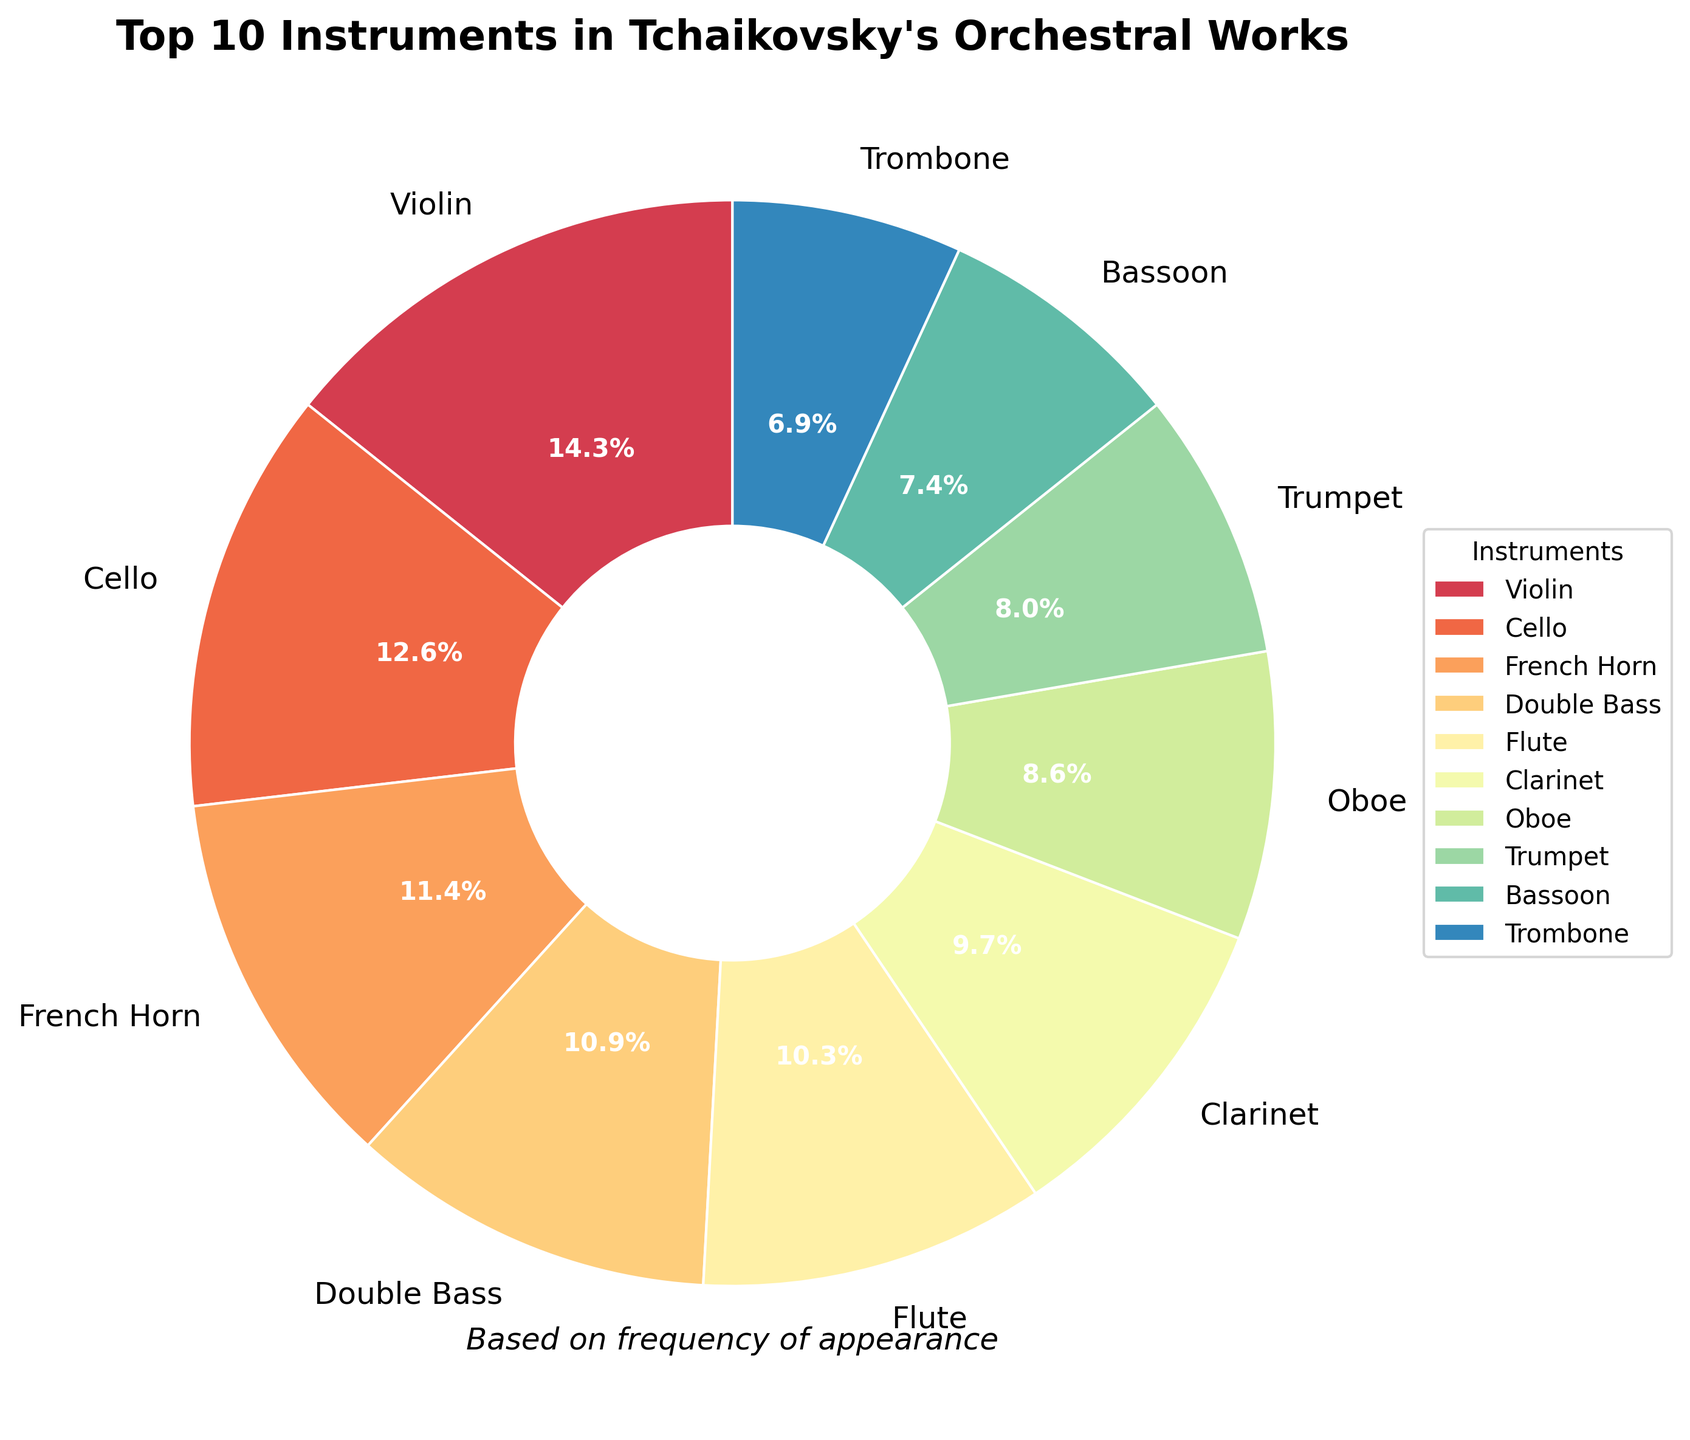What instrument is featured the most in Tchaikovsky's orchestral works? The figure shows a pie chart with frequencies of various instruments, and the instrument with the largest segment represents the most featured one.
Answer: Violin Which instrument has a higher frequency, Trumpet or Trombone? The pie chart shows the frequency of each instrument's appearance. By comparing the sizes of the Trumpet and Trombone segments, the Trumpet has a slightly larger segment.
Answer: Trumpet What is the total percentage of string instruments (Violin, Cello, Double Bass) in the chart? First, find the percentage of each string instrument in the top 10 from the chart: Violin (25%), Cello (22%), Double Bass (19%). Add these percentages together: 25% + 22% + 19% = 66%.
Answer: 66% Which instrument has the smallest frequency among the top 10? The segment with the smallest size among the top 10 in the pie chart represents the instrument with the smallest frequency.
Answer: Oboe How many more times does the Violin appear compared to the Timpani? The pie chart shows the frequencies of each instrument's appearance: Violin (25) and Timpani (10). Subtract the frequency of the Timpani from the Violin: 25 - 10 = 15.
Answer: 15 What is the combined percentage of the French Horn and the Clarinet? Find the percentages for French Horn (20%) and Clarinet (17%) from the pie chart. Add these percentages together: 20% + 17% = 37%.
Answer: 37% Compare the frequencies of the Flute and the Violin. Which one appears less, and by how much? The pie chart's frequencies show Flute (18) and Violin (25). Subtract the Flute's frequency from the Violin's frequency: 25 - 18 = 7. The Flute appears 7 times less.
Answer: Flute, by 7 How does the frequency of the Bassoon compare to the frequency of the Trumpet? From the pie chart, Bassoon and Trumpet have frequencies. Trumpet appears more often. By counting, Trumpet is 14 and Bassoon is 13, so Trumpet appears 1 more time.
Answer: Trumpet, by 1 What is the average frequency of the top 5 instruments? The top 5 instruments are Violin (25), Cello (22), Double Bass (19), Flute (18), and French Horn (20). Add these frequencies and divide by 5: (25 + 22 + 19 + 18 + 20) / 5 = 104 / 5 = 20.8.
Answer: 20.8 Is there an equal frequency among any of the instruments in the top 10? Examine each segment in the pie chart. No two segments have the same frequency in the top 10 instruments.
Answer: No 